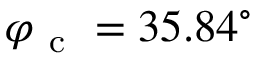Convert formula to latex. <formula><loc_0><loc_0><loc_500><loc_500>\varphi _ { c } = 3 5 . 8 4 ^ { \circ }</formula> 